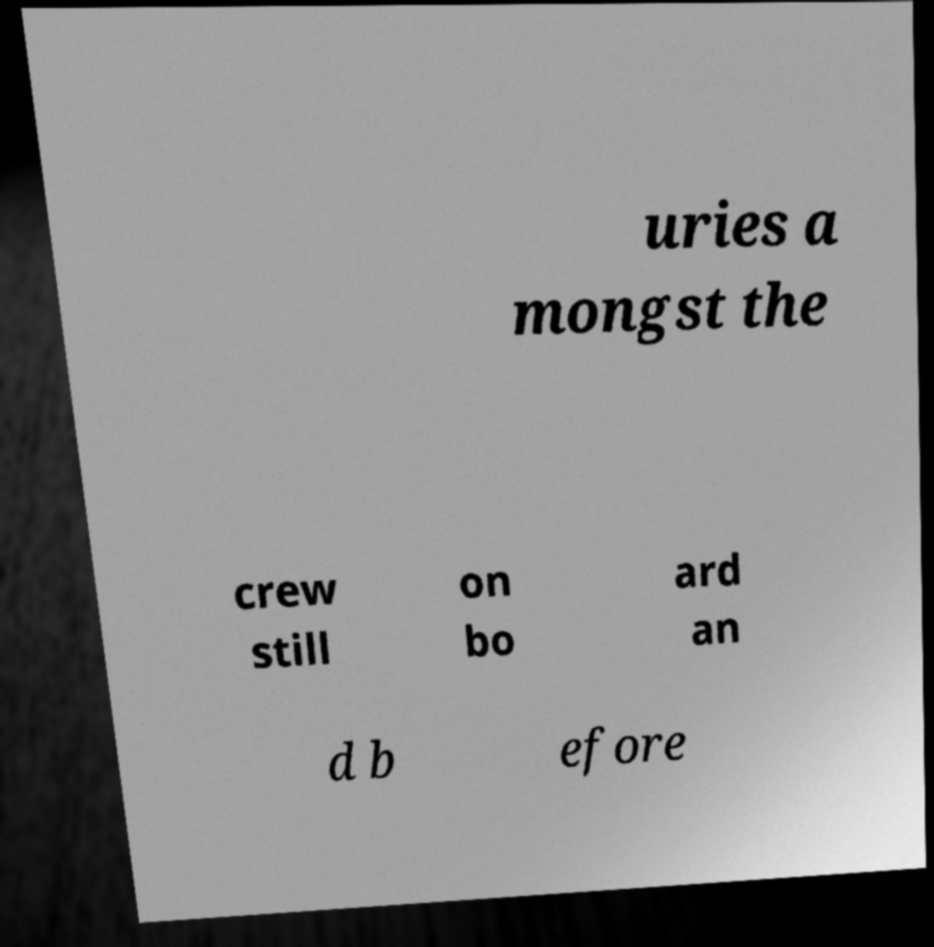Could you assist in decoding the text presented in this image and type it out clearly? uries a mongst the crew still on bo ard an d b efore 